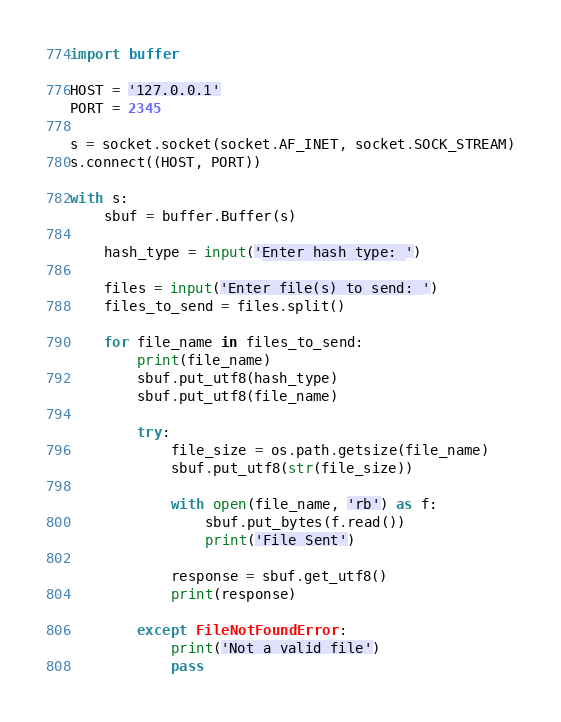Convert code to text. <code><loc_0><loc_0><loc_500><loc_500><_Python_>import buffer

HOST = '127.0.0.1'
PORT = 2345

s = socket.socket(socket.AF_INET, socket.SOCK_STREAM)
s.connect((HOST, PORT))

with s:
    sbuf = buffer.Buffer(s)

    hash_type = input('Enter hash type: ')

    files = input('Enter file(s) to send: ')
    files_to_send = files.split()

    for file_name in files_to_send:
        print(file_name)
        sbuf.put_utf8(hash_type)
        sbuf.put_utf8(file_name)

        try: 
            file_size = os.path.getsize(file_name)
            sbuf.put_utf8(str(file_size))

            with open(file_name, 'rb') as f:
                sbuf.put_bytes(f.read())
                print('File Sent')

            response = sbuf.get_utf8()
            print(response)

        except FileNotFoundError:
            print('Not a valid file')
            pass
</code> 